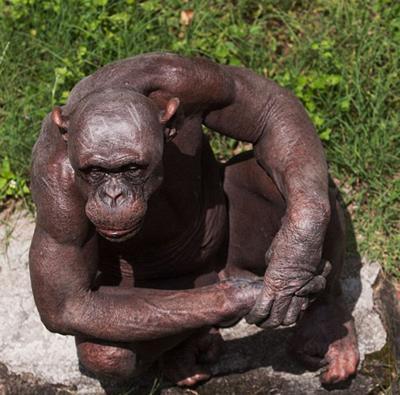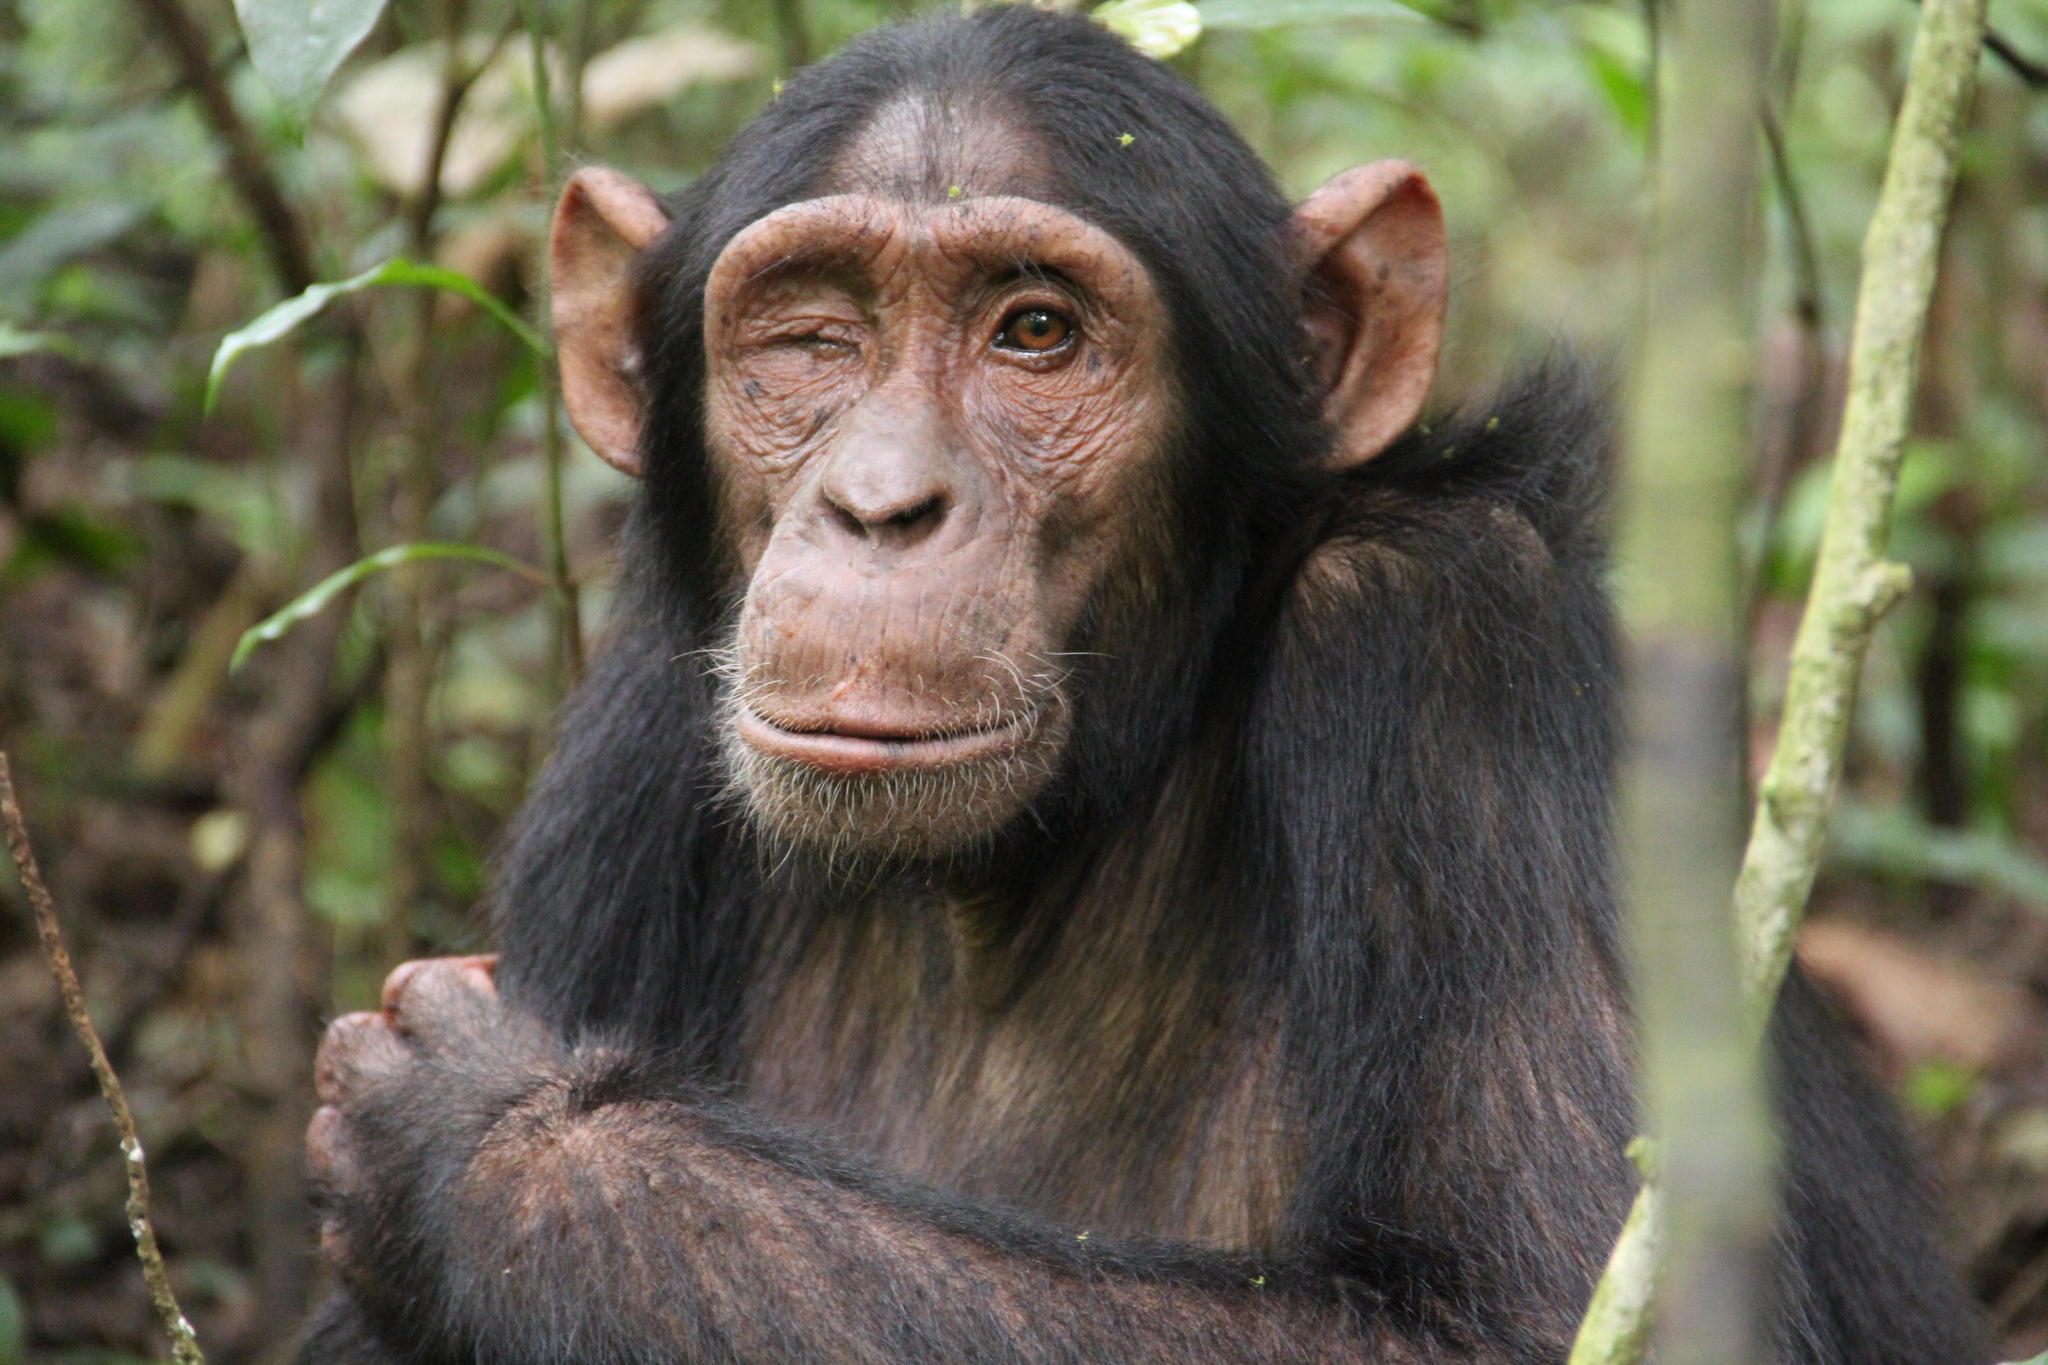The first image is the image on the left, the second image is the image on the right. Considering the images on both sides, is "The animal in the image on the left has both arms resting on its knees." valid? Answer yes or no. Yes. 